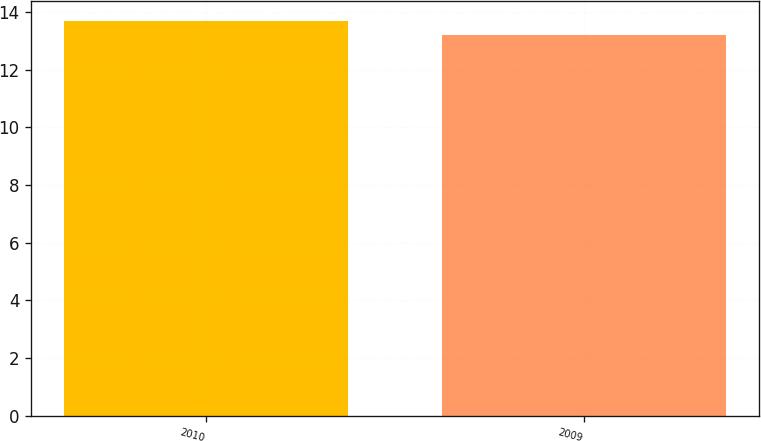Convert chart. <chart><loc_0><loc_0><loc_500><loc_500><bar_chart><fcel>2010<fcel>2009<nl><fcel>13.7<fcel>13.2<nl></chart> 